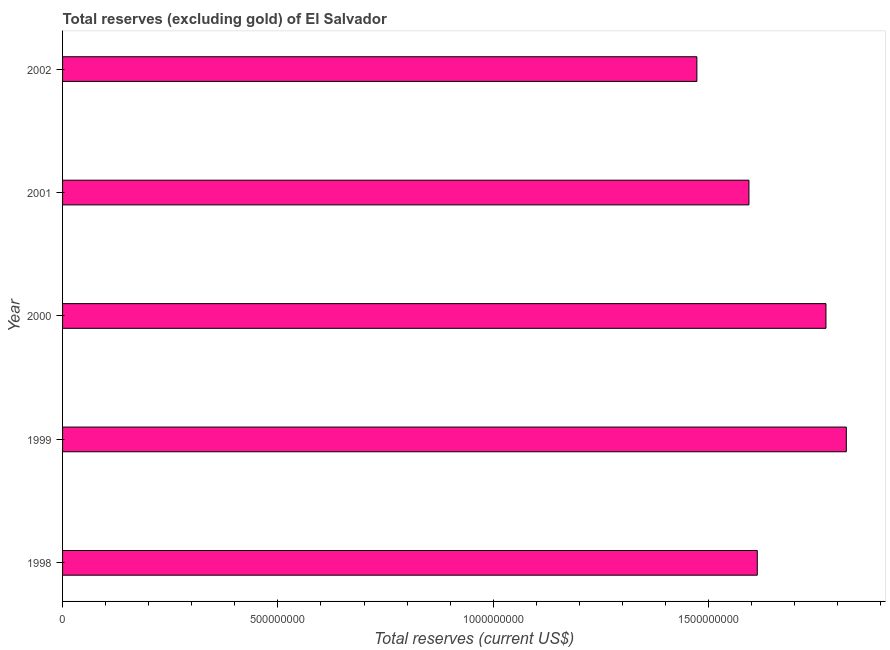Does the graph contain any zero values?
Your answer should be compact. No. What is the title of the graph?
Offer a very short reply. Total reserves (excluding gold) of El Salvador. What is the label or title of the X-axis?
Your answer should be very brief. Total reserves (current US$). What is the label or title of the Y-axis?
Keep it short and to the point. Year. What is the total reserves (excluding gold) in 2000?
Offer a very short reply. 1.77e+09. Across all years, what is the maximum total reserves (excluding gold)?
Provide a succinct answer. 1.82e+09. Across all years, what is the minimum total reserves (excluding gold)?
Your answer should be very brief. 1.47e+09. In which year was the total reserves (excluding gold) maximum?
Offer a terse response. 1999. What is the sum of the total reserves (excluding gold)?
Give a very brief answer. 8.27e+09. What is the difference between the total reserves (excluding gold) in 1999 and 2002?
Provide a short and direct response. 3.47e+08. What is the average total reserves (excluding gold) per year?
Keep it short and to the point. 1.65e+09. What is the median total reserves (excluding gold)?
Your response must be concise. 1.61e+09. What is the ratio of the total reserves (excluding gold) in 1998 to that in 1999?
Your answer should be compact. 0.89. Is the difference between the total reserves (excluding gold) in 1998 and 2002 greater than the difference between any two years?
Make the answer very short. No. What is the difference between the highest and the second highest total reserves (excluding gold)?
Your response must be concise. 4.72e+07. What is the difference between the highest and the lowest total reserves (excluding gold)?
Make the answer very short. 3.47e+08. In how many years, is the total reserves (excluding gold) greater than the average total reserves (excluding gold) taken over all years?
Give a very brief answer. 2. How many bars are there?
Provide a succinct answer. 5. Are all the bars in the graph horizontal?
Make the answer very short. Yes. How many years are there in the graph?
Your response must be concise. 5. What is the difference between two consecutive major ticks on the X-axis?
Offer a very short reply. 5.00e+08. What is the Total reserves (current US$) of 1998?
Keep it short and to the point. 1.61e+09. What is the Total reserves (current US$) of 1999?
Offer a terse response. 1.82e+09. What is the Total reserves (current US$) of 2000?
Provide a short and direct response. 1.77e+09. What is the Total reserves (current US$) in 2001?
Make the answer very short. 1.59e+09. What is the Total reserves (current US$) in 2002?
Your answer should be very brief. 1.47e+09. What is the difference between the Total reserves (current US$) in 1998 and 1999?
Your answer should be compact. -2.07e+08. What is the difference between the Total reserves (current US$) in 1998 and 2000?
Offer a terse response. -1.59e+08. What is the difference between the Total reserves (current US$) in 1998 and 2001?
Provide a short and direct response. 1.94e+07. What is the difference between the Total reserves (current US$) in 1998 and 2002?
Give a very brief answer. 1.40e+08. What is the difference between the Total reserves (current US$) in 1999 and 2000?
Provide a short and direct response. 4.72e+07. What is the difference between the Total reserves (current US$) in 1999 and 2001?
Give a very brief answer. 2.26e+08. What is the difference between the Total reserves (current US$) in 1999 and 2002?
Offer a very short reply. 3.47e+08. What is the difference between the Total reserves (current US$) in 2000 and 2001?
Give a very brief answer. 1.79e+08. What is the difference between the Total reserves (current US$) in 2000 and 2002?
Provide a succinct answer. 3.00e+08. What is the difference between the Total reserves (current US$) in 2001 and 2002?
Provide a short and direct response. 1.21e+08. What is the ratio of the Total reserves (current US$) in 1998 to that in 1999?
Keep it short and to the point. 0.89. What is the ratio of the Total reserves (current US$) in 1998 to that in 2000?
Your response must be concise. 0.91. What is the ratio of the Total reserves (current US$) in 1998 to that in 2002?
Provide a short and direct response. 1.09. What is the ratio of the Total reserves (current US$) in 1999 to that in 2001?
Give a very brief answer. 1.14. What is the ratio of the Total reserves (current US$) in 1999 to that in 2002?
Ensure brevity in your answer.  1.24. What is the ratio of the Total reserves (current US$) in 2000 to that in 2001?
Offer a very short reply. 1.11. What is the ratio of the Total reserves (current US$) in 2000 to that in 2002?
Give a very brief answer. 1.2. What is the ratio of the Total reserves (current US$) in 2001 to that in 2002?
Your answer should be very brief. 1.08. 